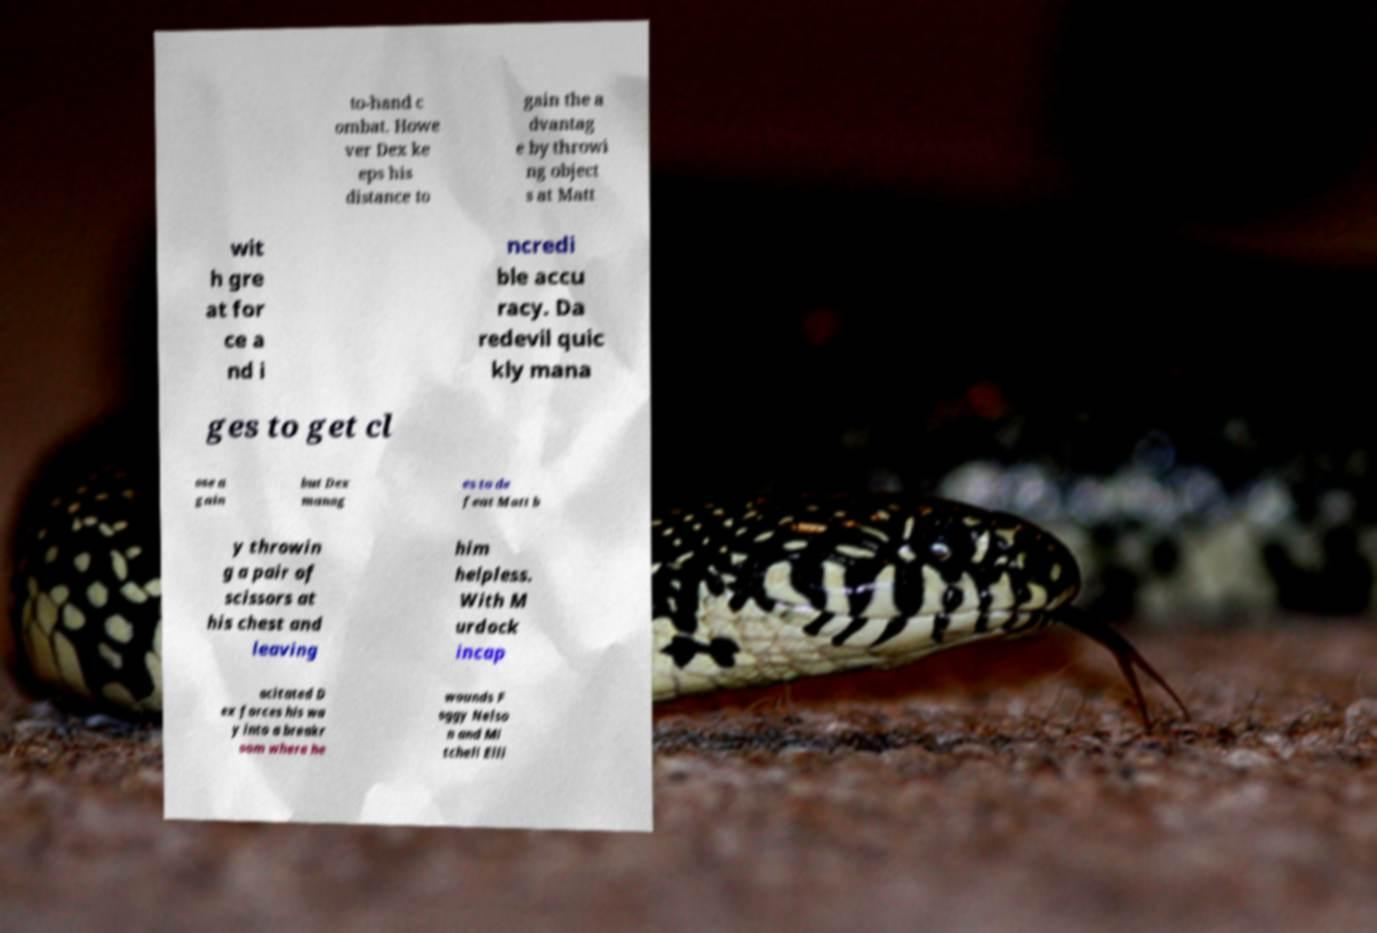What messages or text are displayed in this image? I need them in a readable, typed format. to-hand c ombat. Howe ver Dex ke eps his distance to gain the a dvantag e by throwi ng object s at Matt wit h gre at for ce a nd i ncredi ble accu racy. Da redevil quic kly mana ges to get cl ose a gain but Dex manag es to de feat Matt b y throwin g a pair of scissors at his chest and leaving him helpless. With M urdock incap acitated D ex forces his wa y into a breakr oom where he wounds F oggy Nelso n and Mi tchell Elli 